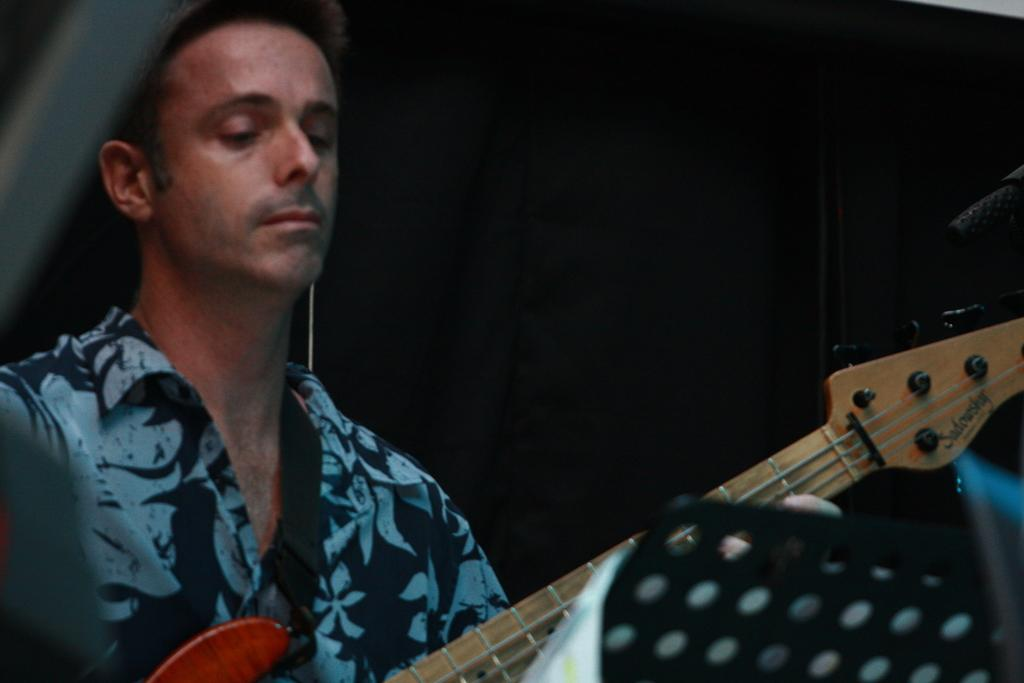Who is the main subject in the image? There is a person in the image. What is the person wearing? The person is wearing a blue shirt. What is the person doing in the image? The person is playing a guitar. What type of whip is the doctor using to treat the man in the image? There is no doctor or whip present in the image. The person is playing a guitar, and there is no indication of any medical treatment or whip usage. 